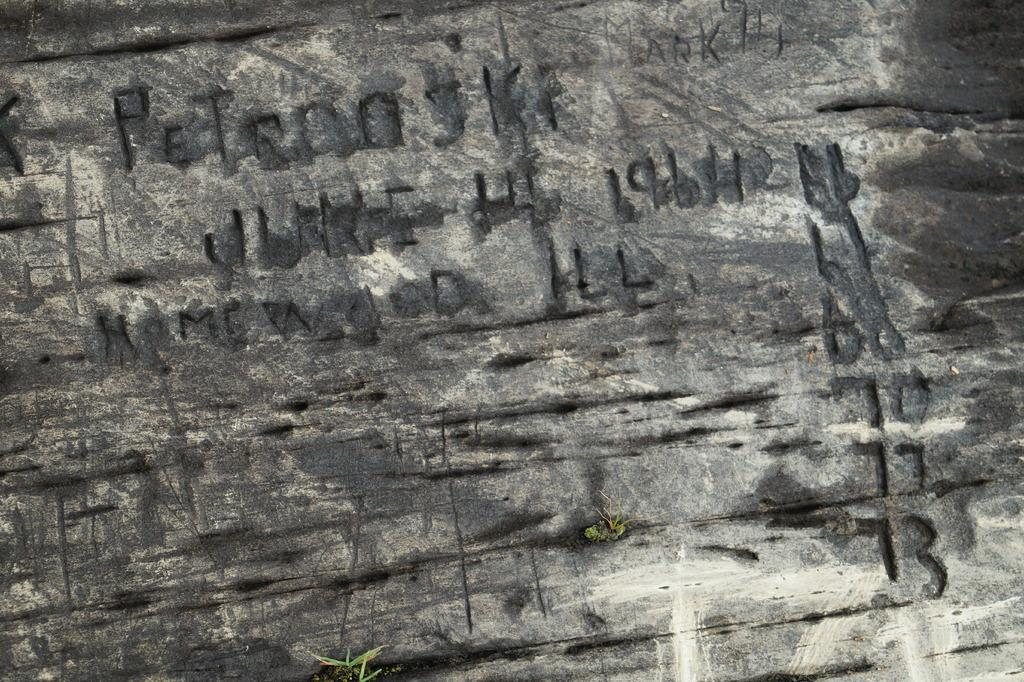What is present on the wall in the image? There is text and numbers on the wall in the image. Can you describe the text on the wall? Unfortunately, the specific content of the text cannot be determined from the image alone. What type of information might the numbers on the wall represent? The numbers on the wall could represent various types of information, such as dates, quantities, or measurements. What type of brass instrument is being played in the image? There is no brass instrument present in the image; it only features a wall with text and numbers. 